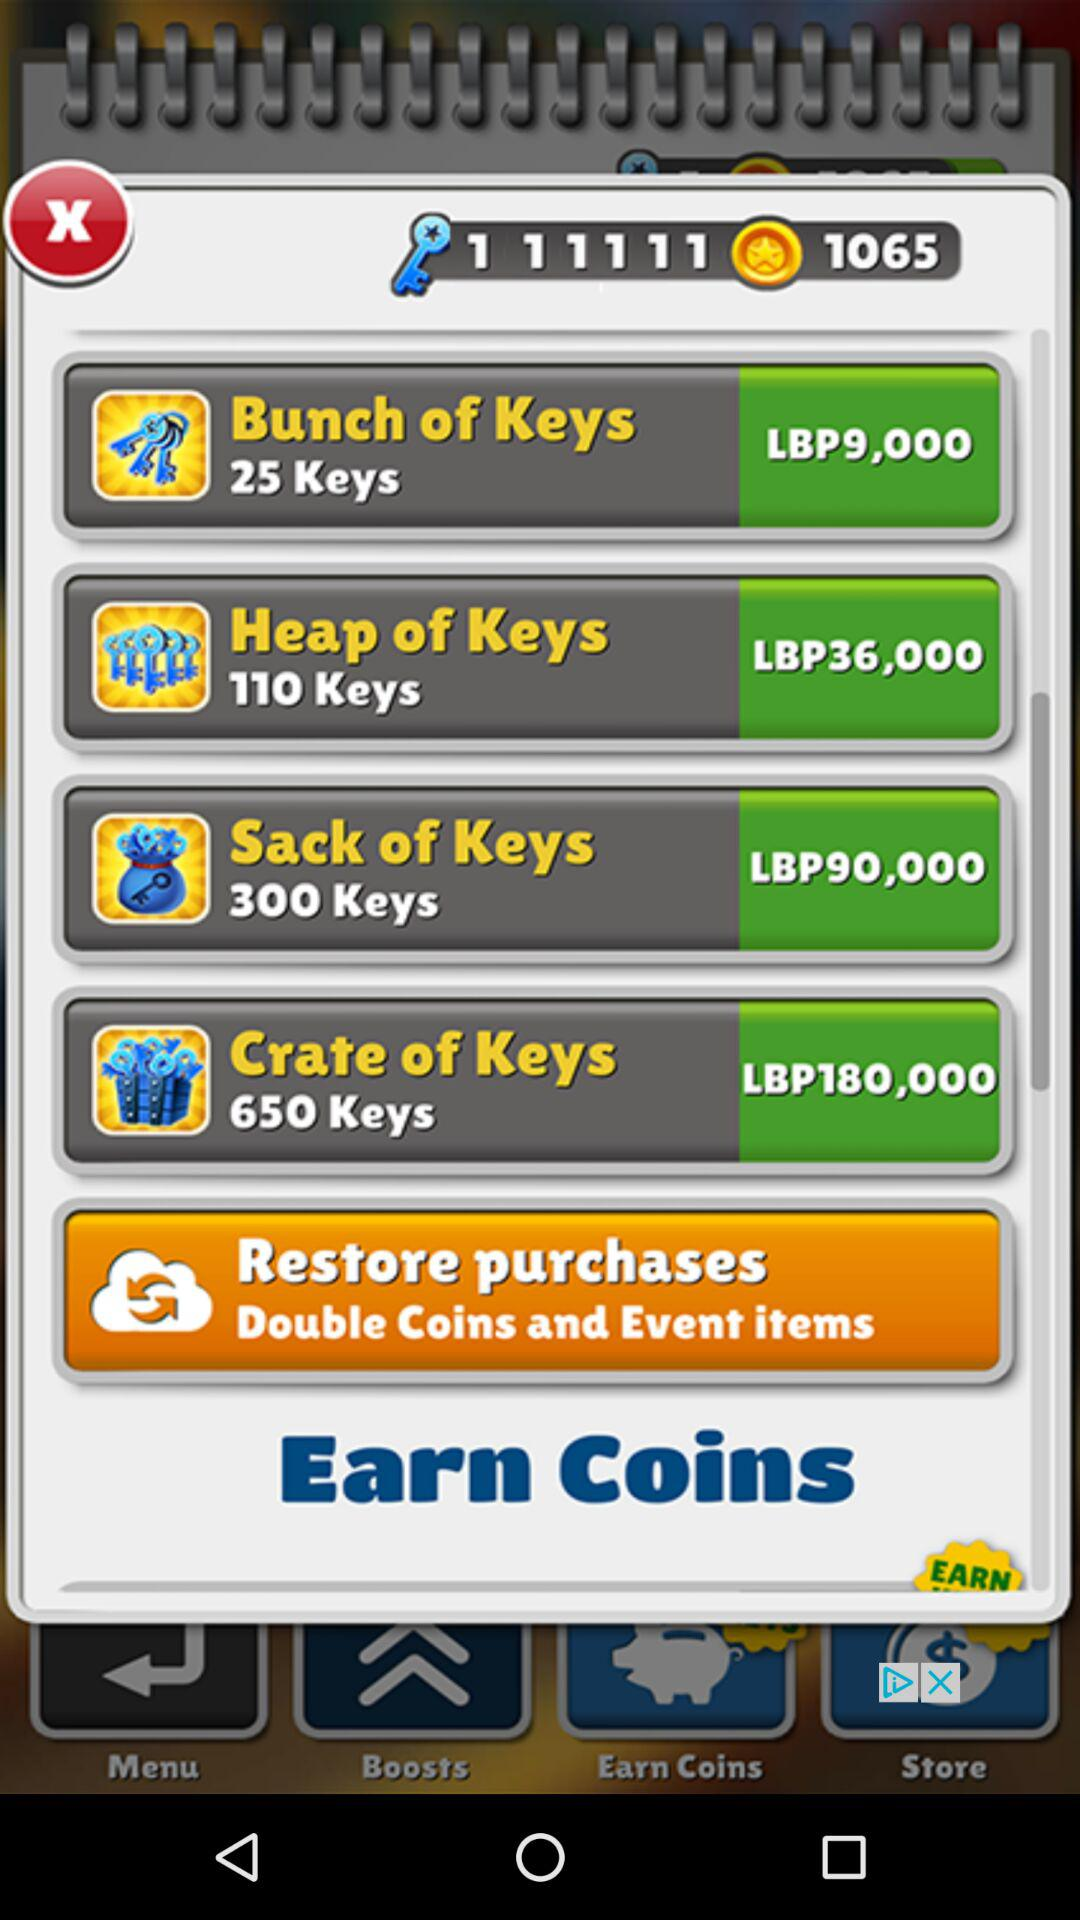What currency is used for the respective keys? The used currency is Lebanese pounds. 